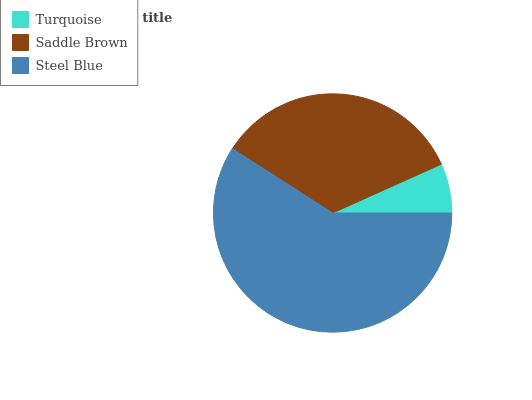Is Turquoise the minimum?
Answer yes or no. Yes. Is Steel Blue the maximum?
Answer yes or no. Yes. Is Saddle Brown the minimum?
Answer yes or no. No. Is Saddle Brown the maximum?
Answer yes or no. No. Is Saddle Brown greater than Turquoise?
Answer yes or no. Yes. Is Turquoise less than Saddle Brown?
Answer yes or no. Yes. Is Turquoise greater than Saddle Brown?
Answer yes or no. No. Is Saddle Brown less than Turquoise?
Answer yes or no. No. Is Saddle Brown the high median?
Answer yes or no. Yes. Is Saddle Brown the low median?
Answer yes or no. Yes. Is Steel Blue the high median?
Answer yes or no. No. Is Steel Blue the low median?
Answer yes or no. No. 